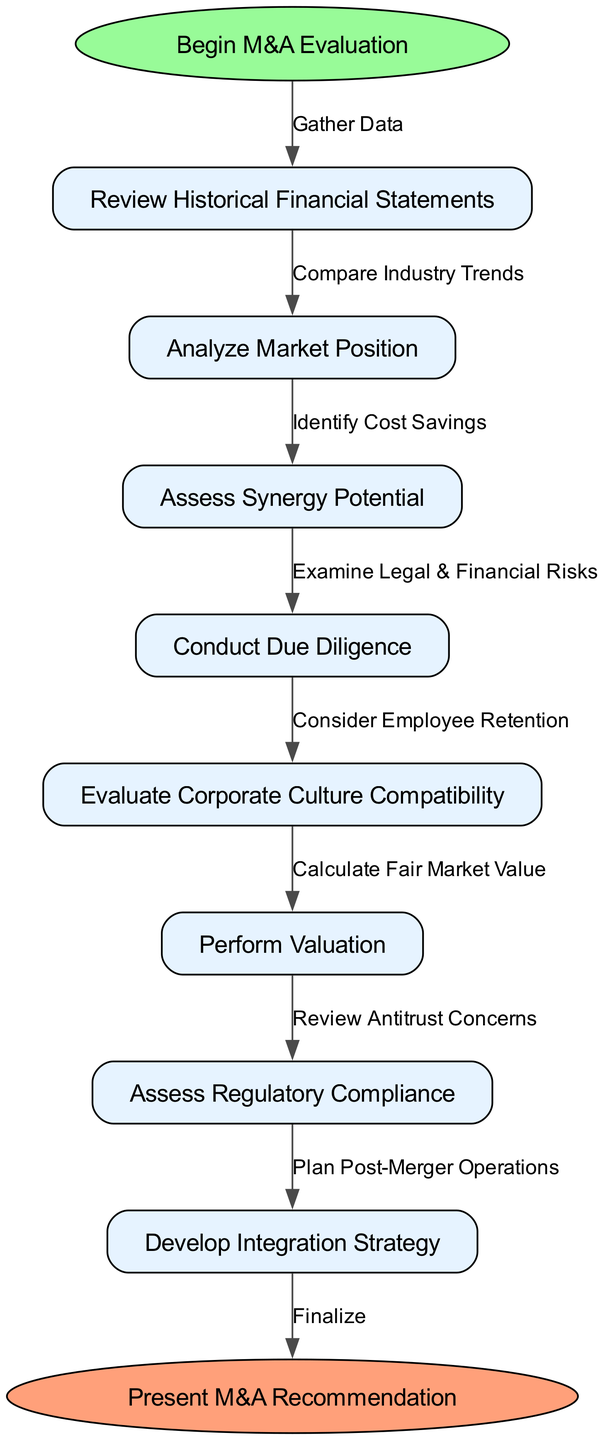What is the starting point of the M&A evaluation process? The diagram indicates the starting point of the M&A evaluation process as "Begin M&A Evaluation," which is clearly stated in the start node.
Answer: Begin M&A Evaluation How many nodes are present in the diagram? To determine the number of nodes, we count the nodes listed in the data: there are 7 nodes for the evaluation steps plus 1 start node and 1 end node, totaling 9 nodes.
Answer: 9 What is the last step before presenting the M&A recommendation? According to the flow of the diagram, the last step before presenting the M&A recommendation is to "Develop Integration Strategy," which is the final node before the end.
Answer: Develop Integration Strategy Which node follows "Assess Synergy Potential"? Reviewing the connections in the diagram reveals that "Conduct Due Diligence" is the immediate node that follows "Assess Synergy Potential."
Answer: Conduct Due Diligence What is the edge label connecting "Analyze Market Position" to "Assess Synergy Potential"? The edge connecting "Analyze Market Position" to "Assess Synergy Potential" is labeled as "Identify Cost Savings," indicating the relation between those two steps.
Answer: Identify Cost Savings How many edges are there in total? The total number of edges can be calculated as the connections between the 8 nodes (7 evaluation steps plus 1 start node), resulting in 8 edges including the final edge to the end node.
Answer: 8 Which node assesses regulatory compliance? Looking at the flow chart, "Assess Regulatory Compliance" is clearly designated as one of the process nodes that is part of the evaluation steps.
Answer: Assess Regulatory Compliance What is the final action as indicated by the end node? The end node specifies that the final action is to "Present M&A Recommendation," clearly outlining the conclusion of the evaluation process.
Answer: Present M&A Recommendation What edge follows "Perform Valuation"? The edge following "Perform Valuation" in the sequence points to "Assess Regulatory Compliance," which shows the progression of the evaluation process.
Answer: Assess Regulatory Compliance 